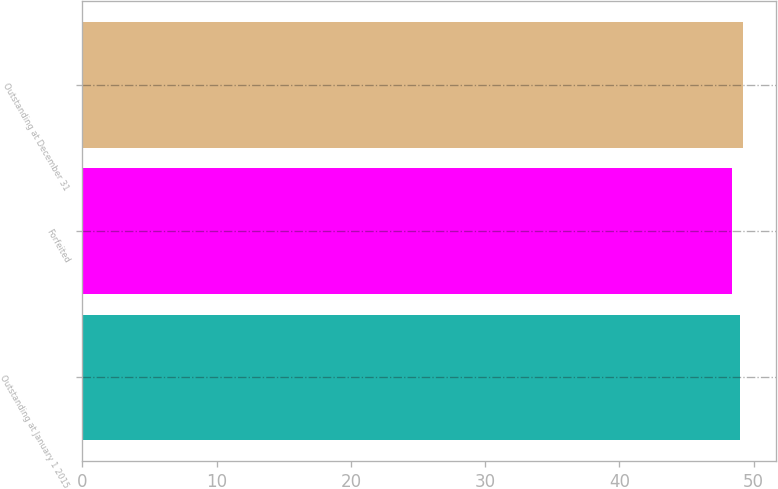Convert chart. <chart><loc_0><loc_0><loc_500><loc_500><bar_chart><fcel>Outstanding at January 1 2015<fcel>Forfeited<fcel>Outstanding at December 31<nl><fcel>48.96<fcel>48.38<fcel>49.18<nl></chart> 